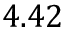Convert formula to latex. <formula><loc_0><loc_0><loc_500><loc_500>4 . 4 2</formula> 